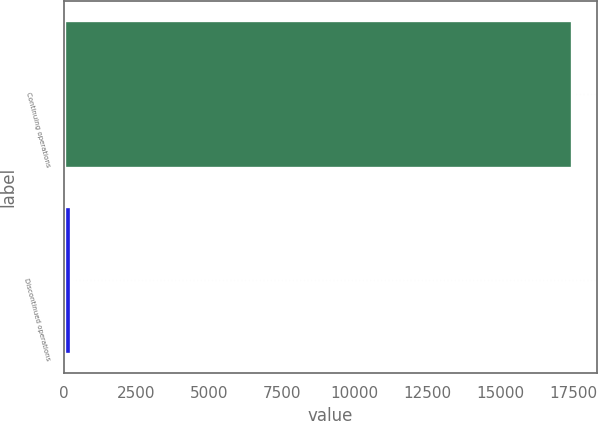Convert chart to OTSL. <chart><loc_0><loc_0><loc_500><loc_500><bar_chart><fcel>Continuing operations<fcel>Discontinued operations<nl><fcel>17455<fcel>252<nl></chart> 